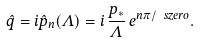Convert formula to latex. <formula><loc_0><loc_0><loc_500><loc_500>\hat { q } = i \hat { p } _ { n } ( \Lambda ) = i \, \frac { p _ { * } } { \Lambda } \, e ^ { n \pi / \ s z e r o } .</formula> 